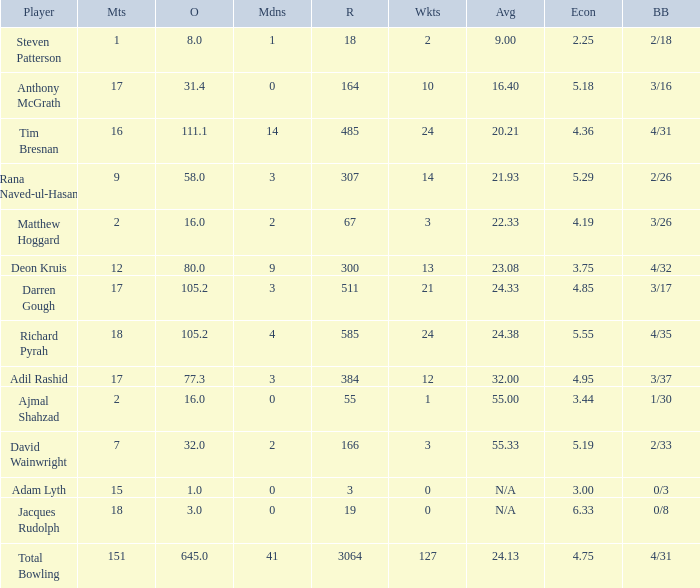What is the lowest Overs with a Run that is 18? 8.0. 